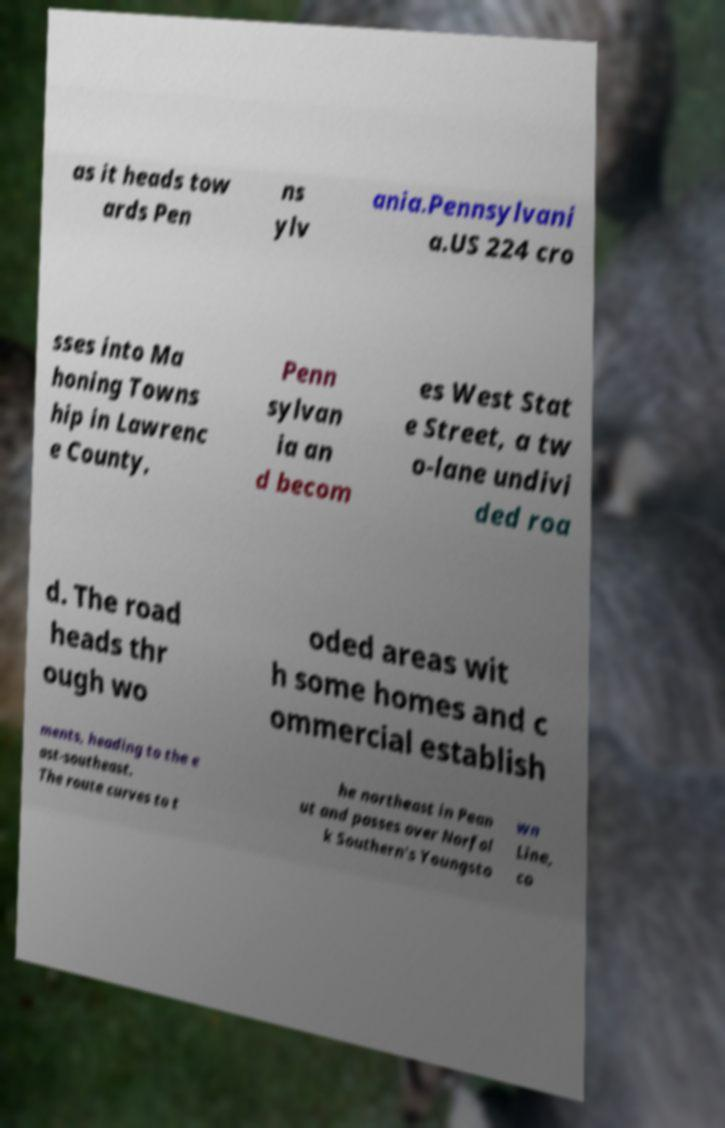There's text embedded in this image that I need extracted. Can you transcribe it verbatim? as it heads tow ards Pen ns ylv ania.Pennsylvani a.US 224 cro sses into Ma honing Towns hip in Lawrenc e County, Penn sylvan ia an d becom es West Stat e Street, a tw o-lane undivi ded roa d. The road heads thr ough wo oded areas wit h some homes and c ommercial establish ments, heading to the e ast-southeast. The route curves to t he northeast in Pean ut and passes over Norfol k Southern's Youngsto wn Line, co 